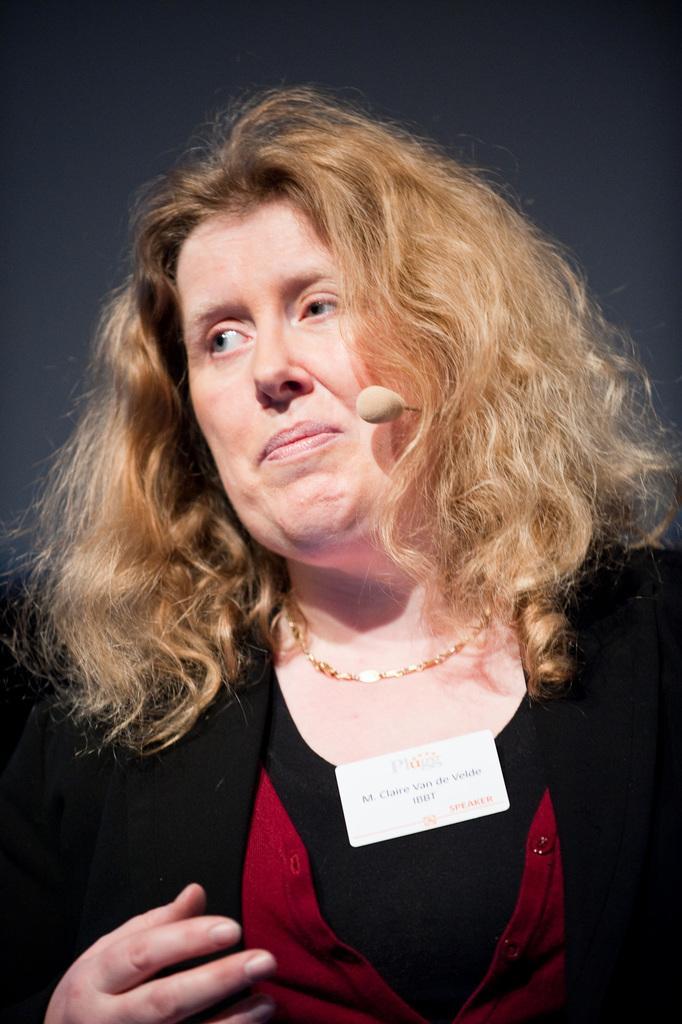How would you summarize this image in a sentence or two? In this image there is a woman who is having a mic. The color of her hair is gold. The girl wearing the black dress with a badge on it. 